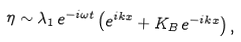Convert formula to latex. <formula><loc_0><loc_0><loc_500><loc_500>\eta \sim \lambda _ { 1 } \, e ^ { - i \omega t } \left ( e ^ { i k x } + K _ { B } \, e ^ { - i k x } \right ) ,</formula> 